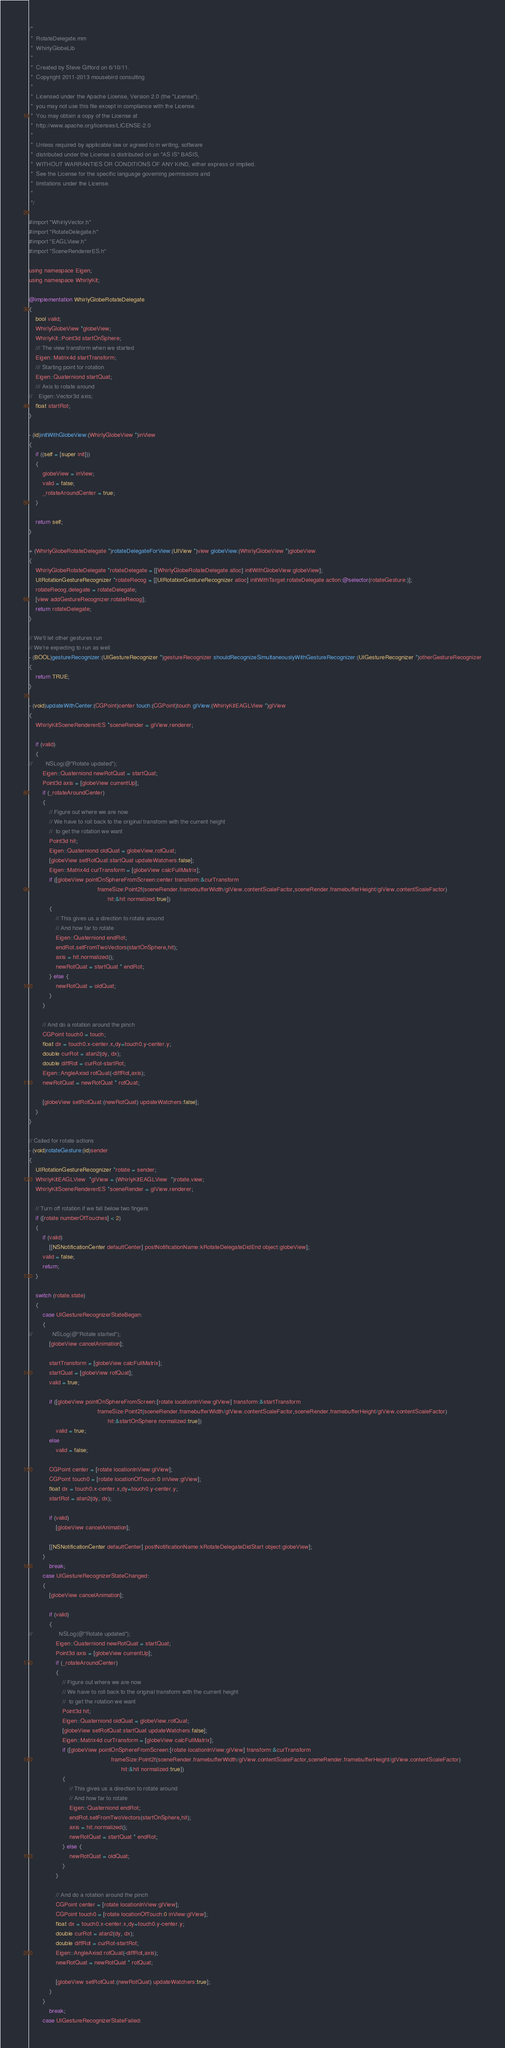Convert code to text. <code><loc_0><loc_0><loc_500><loc_500><_ObjectiveC_>/*
 *  RotateDelegate.mm
 *  WhirlyGlobeLib
 *
 *  Created by Steve Gifford on 6/10/11.
 *  Copyright 2011-2013 mousebird consulting
 *
 *  Licensed under the Apache License, Version 2.0 (the "License");
 *  you may not use this file except in compliance with the License.
 *  You may obtain a copy of the License at
 *  http://www.apache.org/licenses/LICENSE-2.0
 *
 *  Unless required by applicable law or agreed to in writing, software
 *  distributed under the License is distributed on an "AS IS" BASIS,
 *  WITHOUT WARRANTIES OR CONDITIONS OF ANY KIND, either express or implied.
 *  See the License for the specific language governing permissions and
 *  limitations under the License.
 *
 */

#import "WhirlyVector.h"
#import "RotateDelegate.h"
#import "EAGLView.h"
#import "SceneRendererES.h"

using namespace Eigen;
using namespace WhirlyKit;

@implementation WhirlyGlobeRotateDelegate
{
    bool valid;
    WhirlyGlobeView *globeView;
	WhirlyKit::Point3d startOnSphere;
	/// The view transform when we started
	Eigen::Matrix4d startTransform;
    /// Starting point for rotation
    Eigen::Quaterniond startQuat;
    /// Axis to rotate around
//    Eigen::Vector3d axis;
    float startRot;
}

- (id)initWithGlobeView:(WhirlyGlobeView *)inView
{
	if ((self = [super init]))
	{
		globeView = inView;
        valid = false;
        _rotateAroundCenter = true;
	}
	
	return self;
}

+ (WhirlyGlobeRotateDelegate *)rotateDelegateForView:(UIView *)view globeView:(WhirlyGlobeView *)globeView
{
	WhirlyGlobeRotateDelegate *rotateDelegate = [[WhirlyGlobeRotateDelegate alloc] initWithGlobeView:globeView];
    UIRotationGestureRecognizer *rotateRecog = [[UIRotationGestureRecognizer alloc] initWithTarget:rotateDelegate action:@selector(rotateGesture:)];
    rotateRecog.delegate = rotateDelegate;
	[view addGestureRecognizer:rotateRecog];
	return rotateDelegate;
}

// We'll let other gestures run
// We're expecting to run as well
- (BOOL)gestureRecognizer:(UIGestureRecognizer *)gestureRecognizer shouldRecognizeSimultaneouslyWithGestureRecognizer:(UIGestureRecognizer *)otherGestureRecognizer
{
    return TRUE;
}

- (void)updateWithCenter:(CGPoint)center touch:(CGPoint)touch glView:(WhirlyKitEAGLView *)glView
{
	WhirlyKitSceneRendererES *sceneRender = glView.renderer;

    if (valid)
    {
//        NSLog(@"Rotate updated");
        Eigen::Quaterniond newRotQuat = startQuat;
        Point3d axis = [globeView currentUp];
        if (_rotateAroundCenter)
        {
            // Figure out where we are now
            // We have to roll back to the original transform with the current height
            //  to get the rotation we want
            Point3d hit;
            Eigen::Quaterniond oldQuat = globeView.rotQuat;
            [globeView setRotQuat:startQuat updateWatchers:false];
            Eigen::Matrix4d curTransform = [globeView calcFullMatrix];
            if ([globeView pointOnSphereFromScreen:center transform:&curTransform
                                         frameSize:Point2f(sceneRender.framebufferWidth/glView.contentScaleFactor,sceneRender.framebufferHeight/glView.contentScaleFactor)
                                               hit:&hit normalized:true])
            {
                // This gives us a direction to rotate around
                // And how far to rotate
                Eigen::Quaterniond endRot;
                endRot.setFromTwoVectors(startOnSphere,hit);
                axis = hit.normalized();
                newRotQuat = startQuat * endRot;
            } else {
                newRotQuat = oldQuat;
            }
        }
        
        // And do a rotation around the pinch
        CGPoint touch0 = touch;
        float dx = touch0.x-center.x,dy=touch0.y-center.y;
        double curRot = atan2(dy, dx);
        double diffRot = curRot-startRot;
        Eigen::AngleAxisd rotQuat(-diffRot,axis);
        newRotQuat = newRotQuat * rotQuat;
        
        [globeView setRotQuat:(newRotQuat) updateWatchers:false];
    }
}

// Called for rotate actions
- (void)rotateGesture:(id)sender
{
	UIRotationGestureRecognizer *rotate = sender;
	WhirlyKitEAGLView  *glView = (WhirlyKitEAGLView  *)rotate.view;
	WhirlyKitSceneRendererES *sceneRender = glView.renderer;
    
    // Turn off rotation if we fall below two fingers
    if ([rotate numberOfTouches] < 2)
    {
        if (valid)
            [[NSNotificationCenter defaultCenter] postNotificationName:kRotateDelegateDidEnd object:globeView];
        valid = false;
        return;
    }
    
	switch (rotate.state)
	{
		case UIGestureRecognizerStateBegan:
        {
//            NSLog(@"Rotate started");
            [globeView cancelAnimation];

			startTransform = [globeView calcFullMatrix];
            startQuat = [globeView rotQuat];
            valid = true;
            
            if ([globeView pointOnSphereFromScreen:[rotate locationInView:glView] transform:&startTransform
                                         frameSize:Point2f(sceneRender.framebufferWidth/glView.contentScaleFactor,sceneRender.framebufferHeight/glView.contentScaleFactor)
                                               hit:&startOnSphere normalized:true])
                valid = true;
            else
                valid = false;
            
            CGPoint center = [rotate locationInView:glView];
            CGPoint touch0 = [rotate locationOfTouch:0 inView:glView];
            float dx = touch0.x-center.x,dy=touch0.y-center.y;
            startRot = atan2(dy, dx);
            
            if (valid)
                [globeView cancelAnimation];
            
            [[NSNotificationCenter defaultCenter] postNotificationName:kRotateDelegateDidStart object:globeView];
        }
			break;
		case UIGestureRecognizerStateChanged:
        {
            [globeView cancelAnimation];

            if (valid)
            {
//                NSLog(@"Rotate updated");
                Eigen::Quaterniond newRotQuat = startQuat;
                Point3d axis = [globeView currentUp];
                if (_rotateAroundCenter)
                {
                    // Figure out where we are now
                    // We have to roll back to the original transform with the current height
                    //  to get the rotation we want
                    Point3d hit;
                    Eigen::Quaterniond oldQuat = globeView.rotQuat;
                    [globeView setRotQuat:startQuat updateWatchers:false];
                    Eigen::Matrix4d curTransform = [globeView calcFullMatrix];
                    if ([globeView pointOnSphereFromScreen:[rotate locationInView:glView] transform:&curTransform
                                                 frameSize:Point2f(sceneRender.framebufferWidth/glView.contentScaleFactor,sceneRender.framebufferHeight/glView.contentScaleFactor)
                                                       hit:&hit normalized:true])
                    {
                        // This gives us a direction to rotate around
                        // And how far to rotate
                        Eigen::Quaterniond endRot;
                        endRot.setFromTwoVectors(startOnSphere,hit);
                        axis = hit.normalized();
                        newRotQuat = startQuat * endRot;
                    } else {
                        newRotQuat = oldQuat;
                    }
                }
                
                // And do a rotation around the pinch
                CGPoint center = [rotate locationInView:glView];
                CGPoint touch0 = [rotate locationOfTouch:0 inView:glView];
                float dx = touch0.x-center.x,dy=touch0.y-center.y;
                double curRot = atan2(dy, dx);
                double diffRot = curRot-startRot;
                Eigen::AngleAxisd rotQuat(-diffRot,axis);
                newRotQuat = newRotQuat * rotQuat;
                
                [globeView setRotQuat:(newRotQuat) updateWatchers:true];
            }
        }
			break;
        case UIGestureRecognizerStateFailed:</code> 